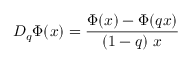<formula> <loc_0><loc_0><loc_500><loc_500>D _ { q } \Phi ( x ) = \frac { \Phi ( x ) - \Phi ( q x ) } { ( 1 - q ) \ x }</formula> 